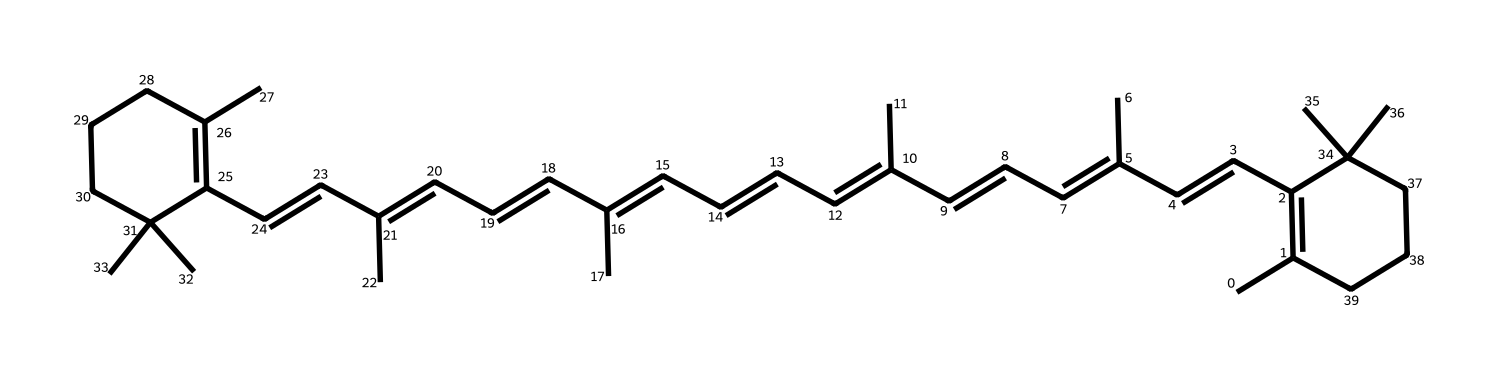What is the systematic name of this chemical? The provided SMILES representation corresponds to beta-carotene, which is a dietary pigment and a precursor to vitamin A. The systematic name incorporates the functional groups and structural classification of the compound.
Answer: beta-carotene How many carbon atoms are in the structure? By analyzing the SMILES notation, we can count the appearances of 'C'. There are 40 carbon atoms present in the structural formula, accounting for the central chain and terminal groups.
Answer: 40 How many double bonds does beta-carotene contain? The structure includes several instances of the notation 'C=C', which indicates double bonds. After careful examination, we find that there are 11 double bonds present in the entire structure.
Answer: 11 What type of compound is beta-carotene categorized as? Given that beta-carotene is known for its coloring properties and presence in various foods, it is classified as a carotenoid. The presence of multiple conjugated double bonds also characterizes it as a natural pigment.
Answer: carotenoid What is the molecular formula of beta-carotene? By summing the counted atoms, we arrive at the molecular formula C40H56. The formula reflects the ratios derived from the structure seen in the SMILES representation.
Answer: C40H56 Why is beta-carotene considered a natural food coloring agent? The structure allows for strong light absorption due to its long conjugated double bond system, which reflects specific wavelengths leading to its characteristic orange color. This optical property is key for its usage as a natural coloring agent.
Answer: due to light absorption 